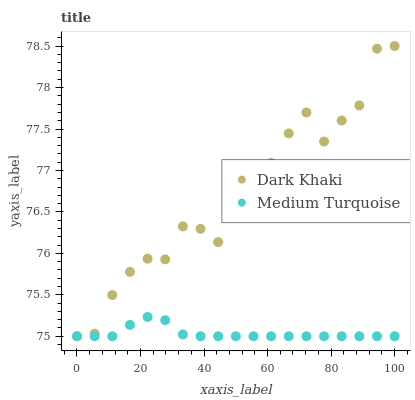Does Medium Turquoise have the minimum area under the curve?
Answer yes or no. Yes. Does Dark Khaki have the maximum area under the curve?
Answer yes or no. Yes. Does Medium Turquoise have the maximum area under the curve?
Answer yes or no. No. Is Medium Turquoise the smoothest?
Answer yes or no. Yes. Is Dark Khaki the roughest?
Answer yes or no. Yes. Is Medium Turquoise the roughest?
Answer yes or no. No. Does Dark Khaki have the lowest value?
Answer yes or no. Yes. Does Dark Khaki have the highest value?
Answer yes or no. Yes. Does Medium Turquoise have the highest value?
Answer yes or no. No. Does Medium Turquoise intersect Dark Khaki?
Answer yes or no. Yes. Is Medium Turquoise less than Dark Khaki?
Answer yes or no. No. Is Medium Turquoise greater than Dark Khaki?
Answer yes or no. No. 